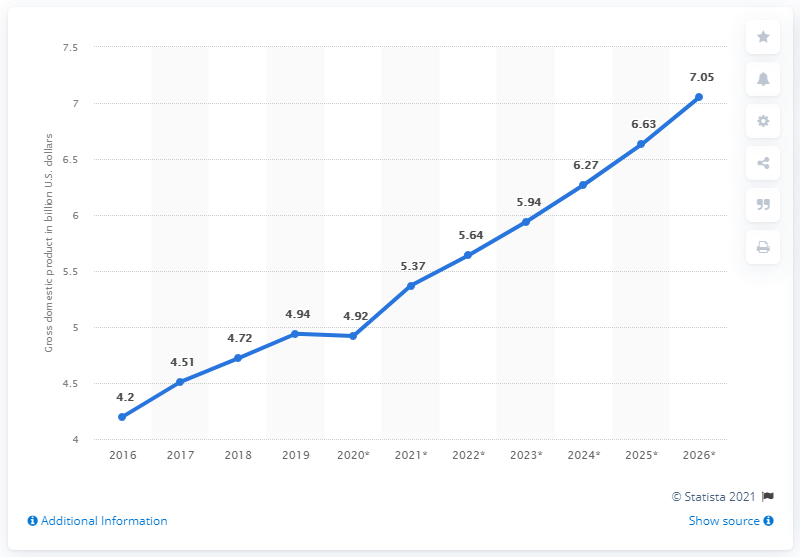Give some essential details in this illustration. In 2019, the gross domestic product (GDP) of Somalia was 4.92. 